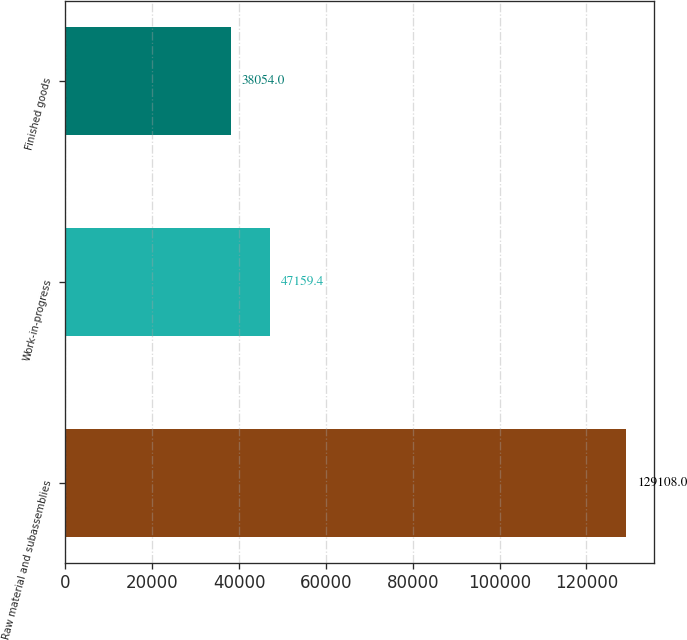<chart> <loc_0><loc_0><loc_500><loc_500><bar_chart><fcel>Raw material and subassemblies<fcel>Work-in-progress<fcel>Finished goods<nl><fcel>129108<fcel>47159.4<fcel>38054<nl></chart> 